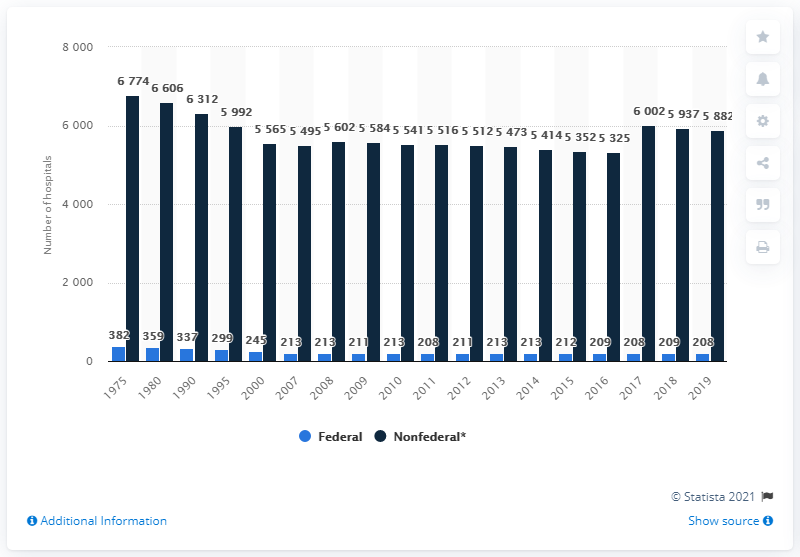Specify some key components in this picture. The number of federal hospitals in 2019 was 208. 